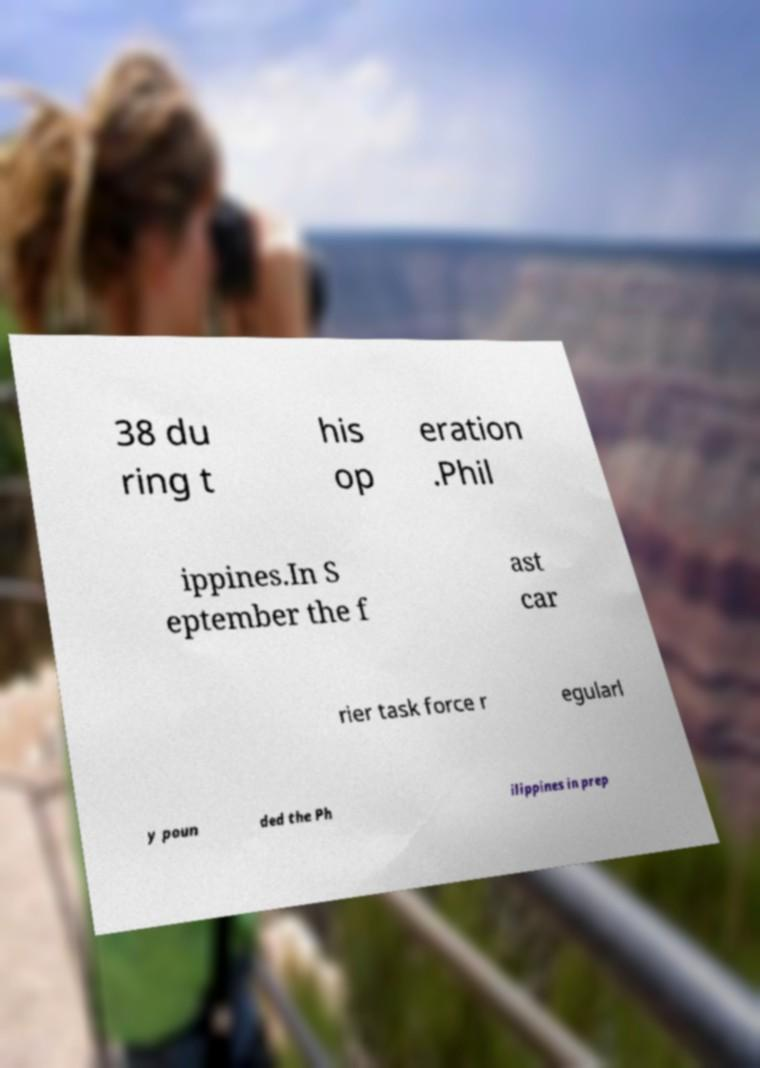There's text embedded in this image that I need extracted. Can you transcribe it verbatim? 38 du ring t his op eration .Phil ippines.In S eptember the f ast car rier task force r egularl y poun ded the Ph ilippines in prep 